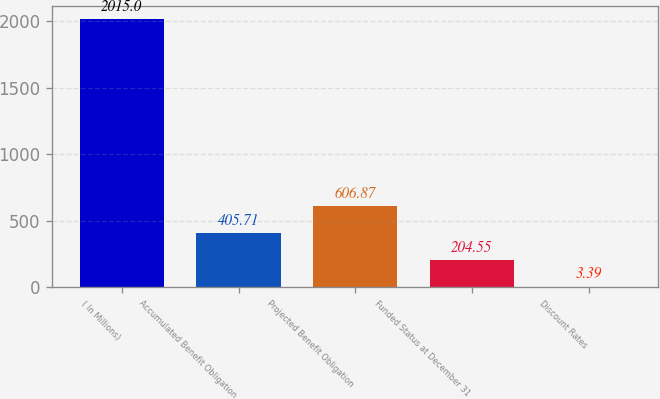Convert chart to OTSL. <chart><loc_0><loc_0><loc_500><loc_500><bar_chart><fcel>( In Millions)<fcel>Accumulated Benefit Obligation<fcel>Projected Benefit Obligation<fcel>Funded Status at December 31<fcel>Discount Rates<nl><fcel>2015<fcel>405.71<fcel>606.87<fcel>204.55<fcel>3.39<nl></chart> 